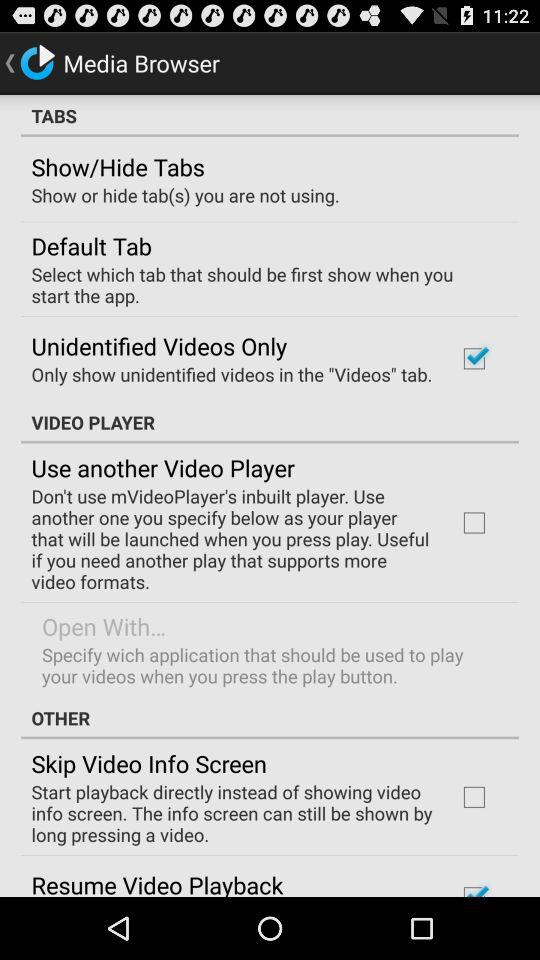How many items are in the Tabs section?
Answer the question using a single word or phrase. 3 